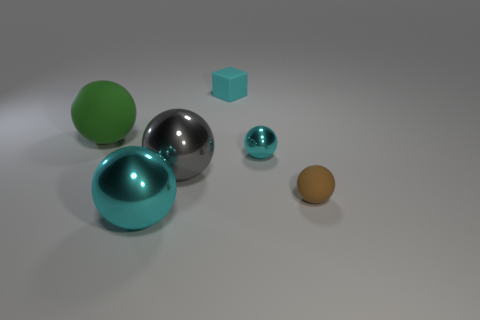Subtract all large cyan spheres. How many spheres are left? 4 Subtract 2 spheres. How many spheres are left? 3 Subtract all gray spheres. How many spheres are left? 4 Add 4 large green rubber spheres. How many objects exist? 10 Subtract all blue balls. Subtract all brown blocks. How many balls are left? 5 Subtract all blocks. How many objects are left? 5 Add 6 purple objects. How many purple objects exist? 6 Subtract 0 purple cubes. How many objects are left? 6 Subtract all tiny brown matte objects. Subtract all small cyan rubber blocks. How many objects are left? 4 Add 3 small cyan metallic objects. How many small cyan metallic objects are left? 4 